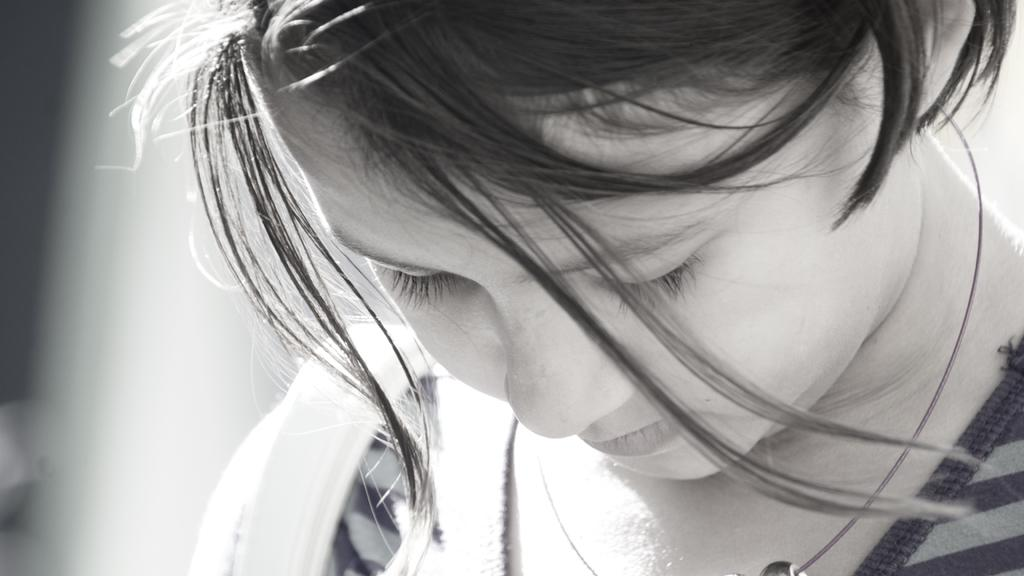What is the color scheme of the image? The image is black and white. Can you describe the main subject of the image? There is a person in the image. What can be observed about the background of the image? The background of the image is blurred. What historical event is being represented in the image? There is no indication of a specific historical event being represented in the image, as it is a black and white image of a person with a blurred background. 